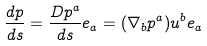<formula> <loc_0><loc_0><loc_500><loc_500>\frac { d p } { d s } = \frac { D p ^ { a } } { d s } e _ { a } = ( \nabla _ { b } p ^ { a } ) u ^ { b } e _ { a }</formula> 